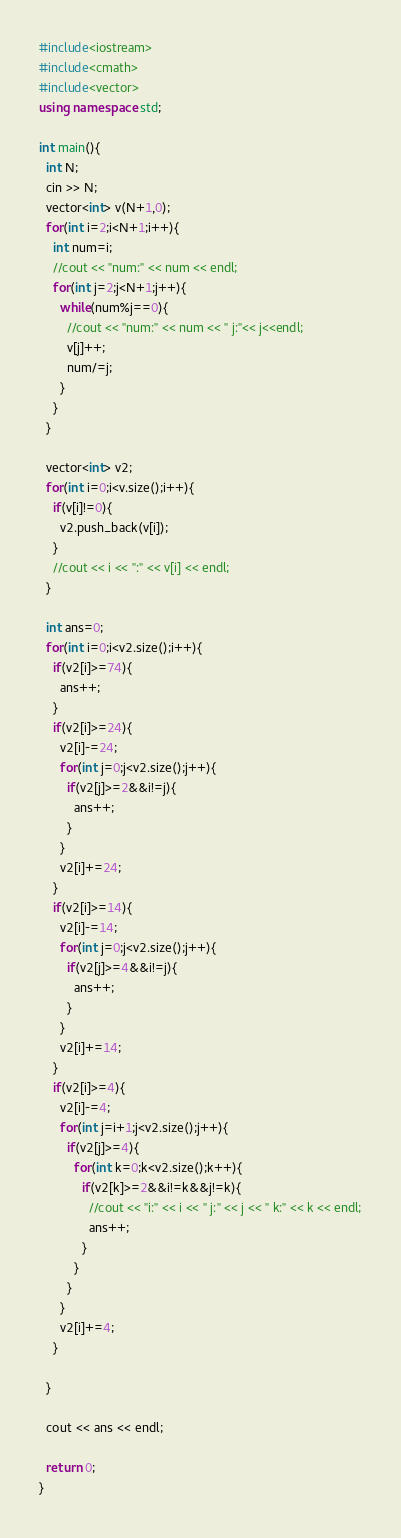<code> <loc_0><loc_0><loc_500><loc_500><_C++_>#include<iostream>
#include<cmath>
#include<vector>
using namespace std;

int main(){
  int N;
  cin >> N;
  vector<int> v(N+1,0);
  for(int i=2;i<N+1;i++){
	int num=i;
	//cout << "num:" << num << endl;
	for(int j=2;j<N+1;j++){
	  while(num%j==0){	
		//cout << "num:" << num << " j:"<< j<<endl;
		v[j]++;
		num/=j;	
	  }
	}
  }
  
  vector<int> v2;
  for(int i=0;i<v.size();i++){
	if(v[i]!=0){
	  v2.push_back(v[i]);
	}
	//cout << i << ":" << v[i] << endl;
  }
  
  int ans=0;
  for(int i=0;i<v2.size();i++){
	if(v2[i]>=74){
	  ans++;
	}
	if(v2[i]>=24){
	  v2[i]-=24;
	  for(int j=0;j<v2.size();j++){
		if(v2[j]>=2&&i!=j){
		  ans++;
		}
	  }
	  v2[i]+=24;
	}
	if(v2[i]>=14){
	  v2[i]-=14;
	  for(int j=0;j<v2.size();j++){
		if(v2[j]>=4&&i!=j){
		  ans++;
		}
	  }
	  v2[i]+=14;
	}
	if(v2[i]>=4){
	  v2[i]-=4;
	  for(int j=i+1;j<v2.size();j++){
		if(v2[j]>=4){
		  for(int k=0;k<v2.size();k++){
			if(v2[k]>=2&&i!=k&&j!=k){
			  //cout << "i:" << i << " j:" << j << " k:" << k << endl;
			  ans++;
			}
		  }
		}
	  }
	  v2[i]+=4;
	}
	
  }
		
  cout << ans << endl;

  return 0;
}</code> 